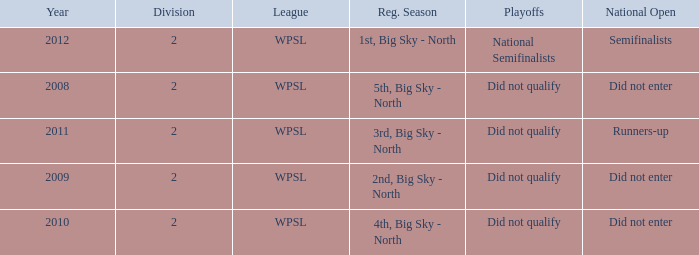What league was involved in 2008? WPSL. 